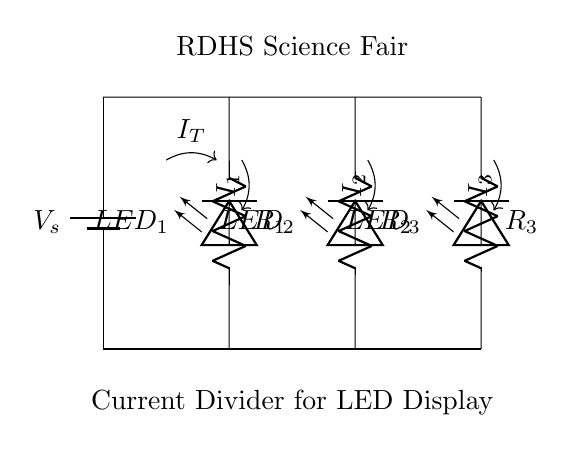What is the source voltage in this circuit? The source voltage is denoted as \( V_s \) at the top of the circuit, representing the potential difference supplied across the parallel resistors.
Answer: Vs How many resistors are present in the circuit? There are three resistors labeled as \( R_1 \), \( R_2 \), and \( R_3 \) in the diagram, indicating that the total count is three.
Answer: 3 What does \( I_T \) represent? \( I_T \) represents the total current entering the parallel circuit before it splits up among the branches with resistors and LEDs.
Answer: Total current Which LED is connected to \( R_2 \)? The LED connected to \( R_2 \) is labeled \( LED_2 \), situated parallel to that resistor in the circuit.
Answer: LED_2 What happens to the current as it passes through the resistors? As the current passes through the resistors, it divides among the three branches, where each branch (resistor and LED) receives a fraction of \( I_T \) based on its resistance value.
Answer: Current divides Which resistor would draw the least current assuming all resistances are equal? If all resistances are equal, each resistor \( R_1 \), \( R_2 \), and \( R_3 \) would draw the same amount of current because they are in parallel. Thus, no resistor stands out for drawing less current under equal conditions.
Answer: Equal current If \( R_1 \) has the highest resistance, which LED will have the smallest current? \( LED_1 \), connected to \( R_1 \), will have the smallest current because, in a current divider, a higher resistance results in a lower share of total current.
Answer: LED_1 